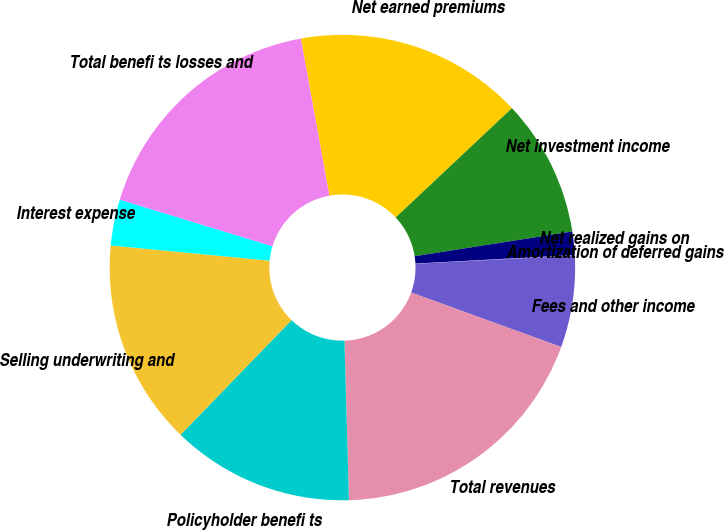<chart> <loc_0><loc_0><loc_500><loc_500><pie_chart><fcel>Net earned premiums<fcel>Net investment income<fcel>Net realized gains on<fcel>Amortization of deferred gains<fcel>Fees and other income<fcel>Total revenues<fcel>Policyholder benefi ts<fcel>Selling underwriting and<fcel>Interest expense<fcel>Total benefi ts losses and<nl><fcel>15.85%<fcel>9.53%<fcel>1.62%<fcel>0.04%<fcel>6.36%<fcel>19.01%<fcel>12.69%<fcel>14.27%<fcel>3.2%<fcel>17.43%<nl></chart> 